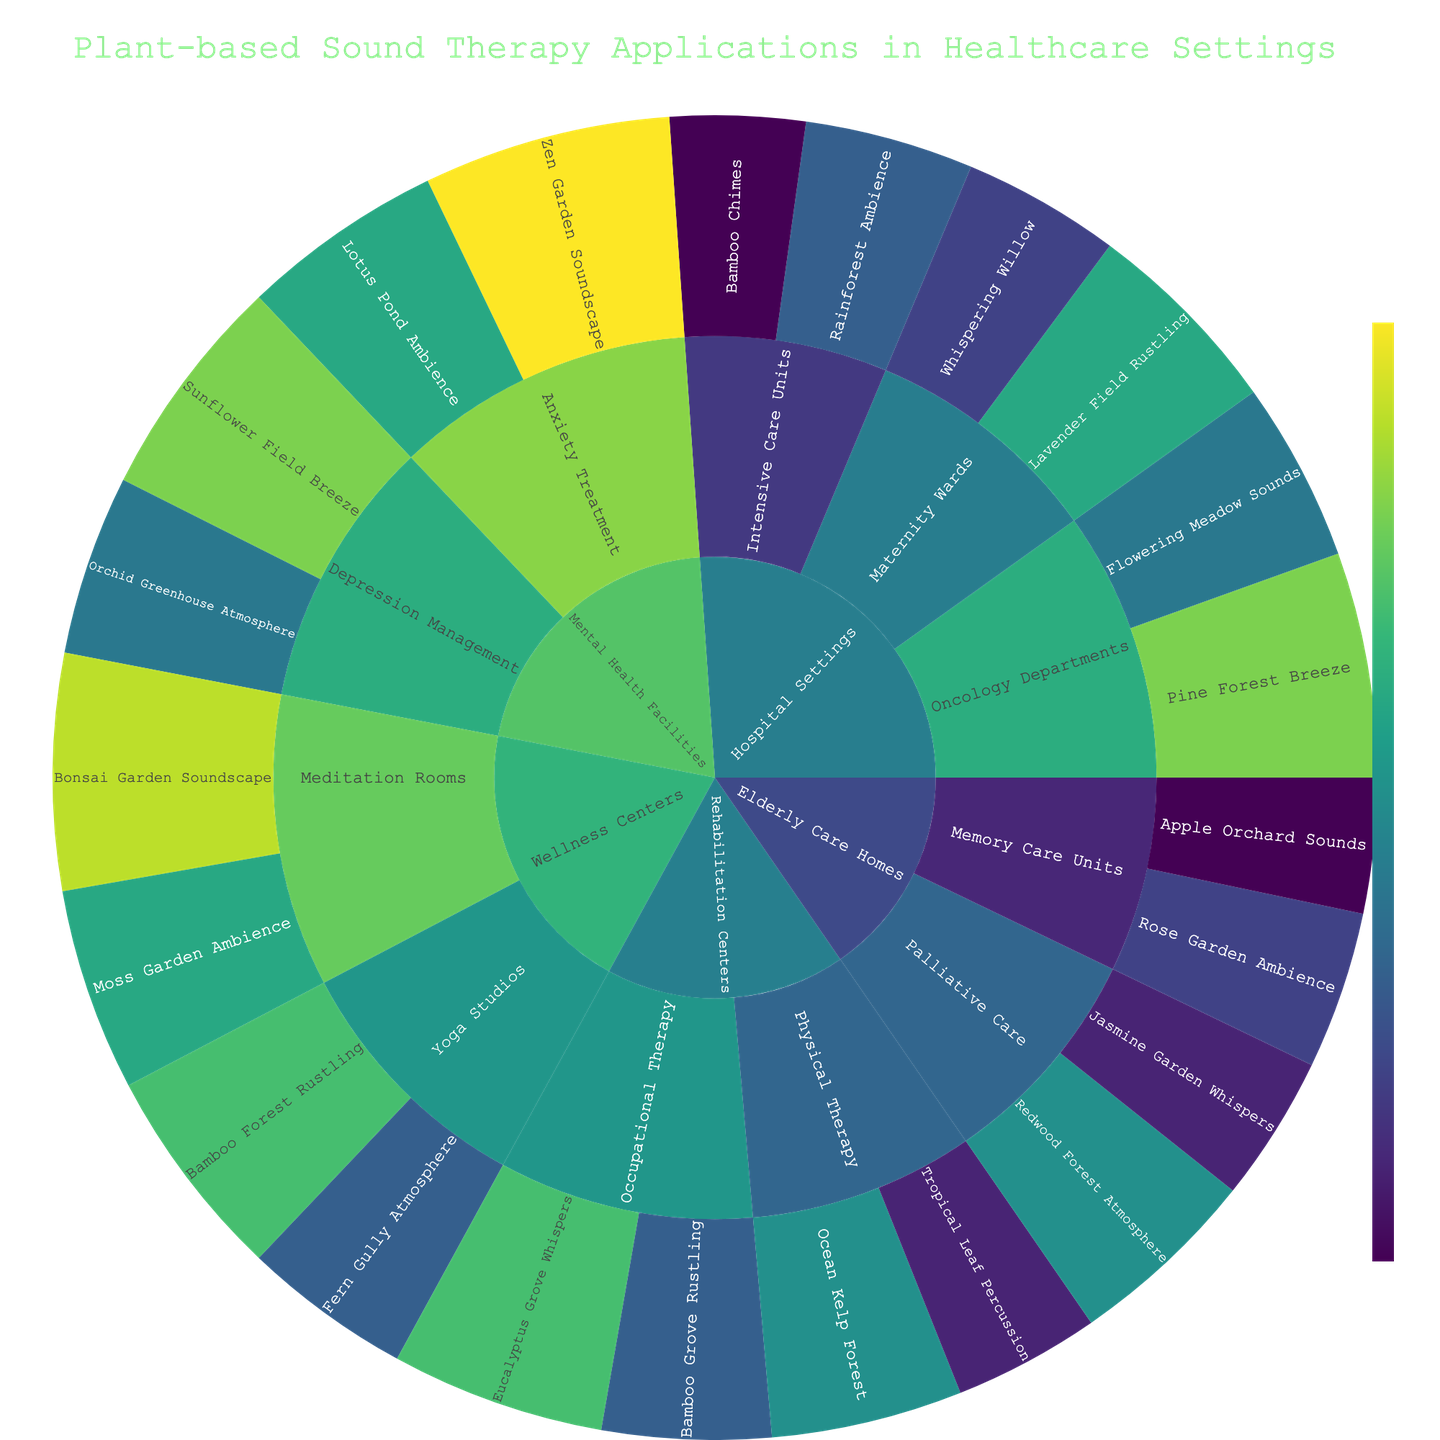What's the title of the sunburst plot? The title is usually displayed prominently at the top of the plot.
Answer: Plant-based Sound Therapy Applications in Healthcare Settings Which application in Mental Health Facilities has the highest value? In Mental Health Facilities, Anxiety Treatment and Depression Management are the subcategories. The applications with their values are Zen Garden Soundscape (22), Lotus Pond Ambience (18), Sunflower Field Breeze (20), and Orchid Greenhouse Atmosphere (16). Zen Garden Soundscape has the highest value of 22.
Answer: Zen Garden Soundscape How many applications are there in Hospital Settings? Hospital Settings is divided into Intensive Care Units, Maternity Wards, and Oncology Departments, with each containing 2 applications. The total number of applications is 2 + 2 + 2 = 6.
Answer: 6 What is the sum of the values for all applications in Rehabilitation Centers? Rehabilitation Centers has Physical Therapy (Ocean Kelp Forest - 17, Tropical Leaf Percussion - 13) and Occupational Therapy (Eucalyptus Grove Whispers - 19, Bamboo Grove Rustling - 15). The total sum is 17 + 13 + 19 + 15 = 64.
Answer: 64 Which subcategory in Wellness Centers has the higher total value? Wellness Centers has Meditation Rooms (Bonsai Garden Soundscape - 21, Moss Garden Ambience - 18) and Yoga Studios (Bamboo Forest Rustling - 19, Fern Gully Atmosphere - 15). The sums are Meditation Rooms (21 + 18 = 39) and Yoga Studios (19 + 15 = 34). Meditation Rooms has the higher total value.
Answer: Meditation Rooms What is the average value of applications in Elderly Care Homes? Elderly Care Homes has Memory Care Units (2 applications: 14, 12) and Palliative Care (2 applications: 17, 13). The total sum is 14 + 12 + 17 + 13 = 56, and the average is 56 / 4 = 14.
Answer: 14 Which application in Mental Health Facilities' Depression Management has a higher value? In Depression Management, the applications are Sunflower Field Breeze (20) and Orchid Greenhouse Atmosphere (16). Sunflower Field Breeze has a higher value.
Answer: Sunflower Field Breeze What are the categories with the highest and lowest total values? Calculate the total values for each category. Hospital Settings (15+12+18+14+20+16=95), Rehabilitation Centers (17+13+19+15=64), Mental Health Facilities (22+18+20+16=76), Elderly Care Homes (14+12+17+13=56), Wellness Centers (21+18+19+15=73). The highest total value is Hospital Settings (95) and the lowest is Elderly Care Homes (56).
Answer: Highest: Hospital Settings, Lowest: Elderly Care Homes What is the total value of all applications in the plot? Sum the values of all applications across all categories: 15+12+18+14+20+16+17+13+19+15+22+18+20+16+14+12+17+13+21+18+19+15 = 354.
Answer: 354 